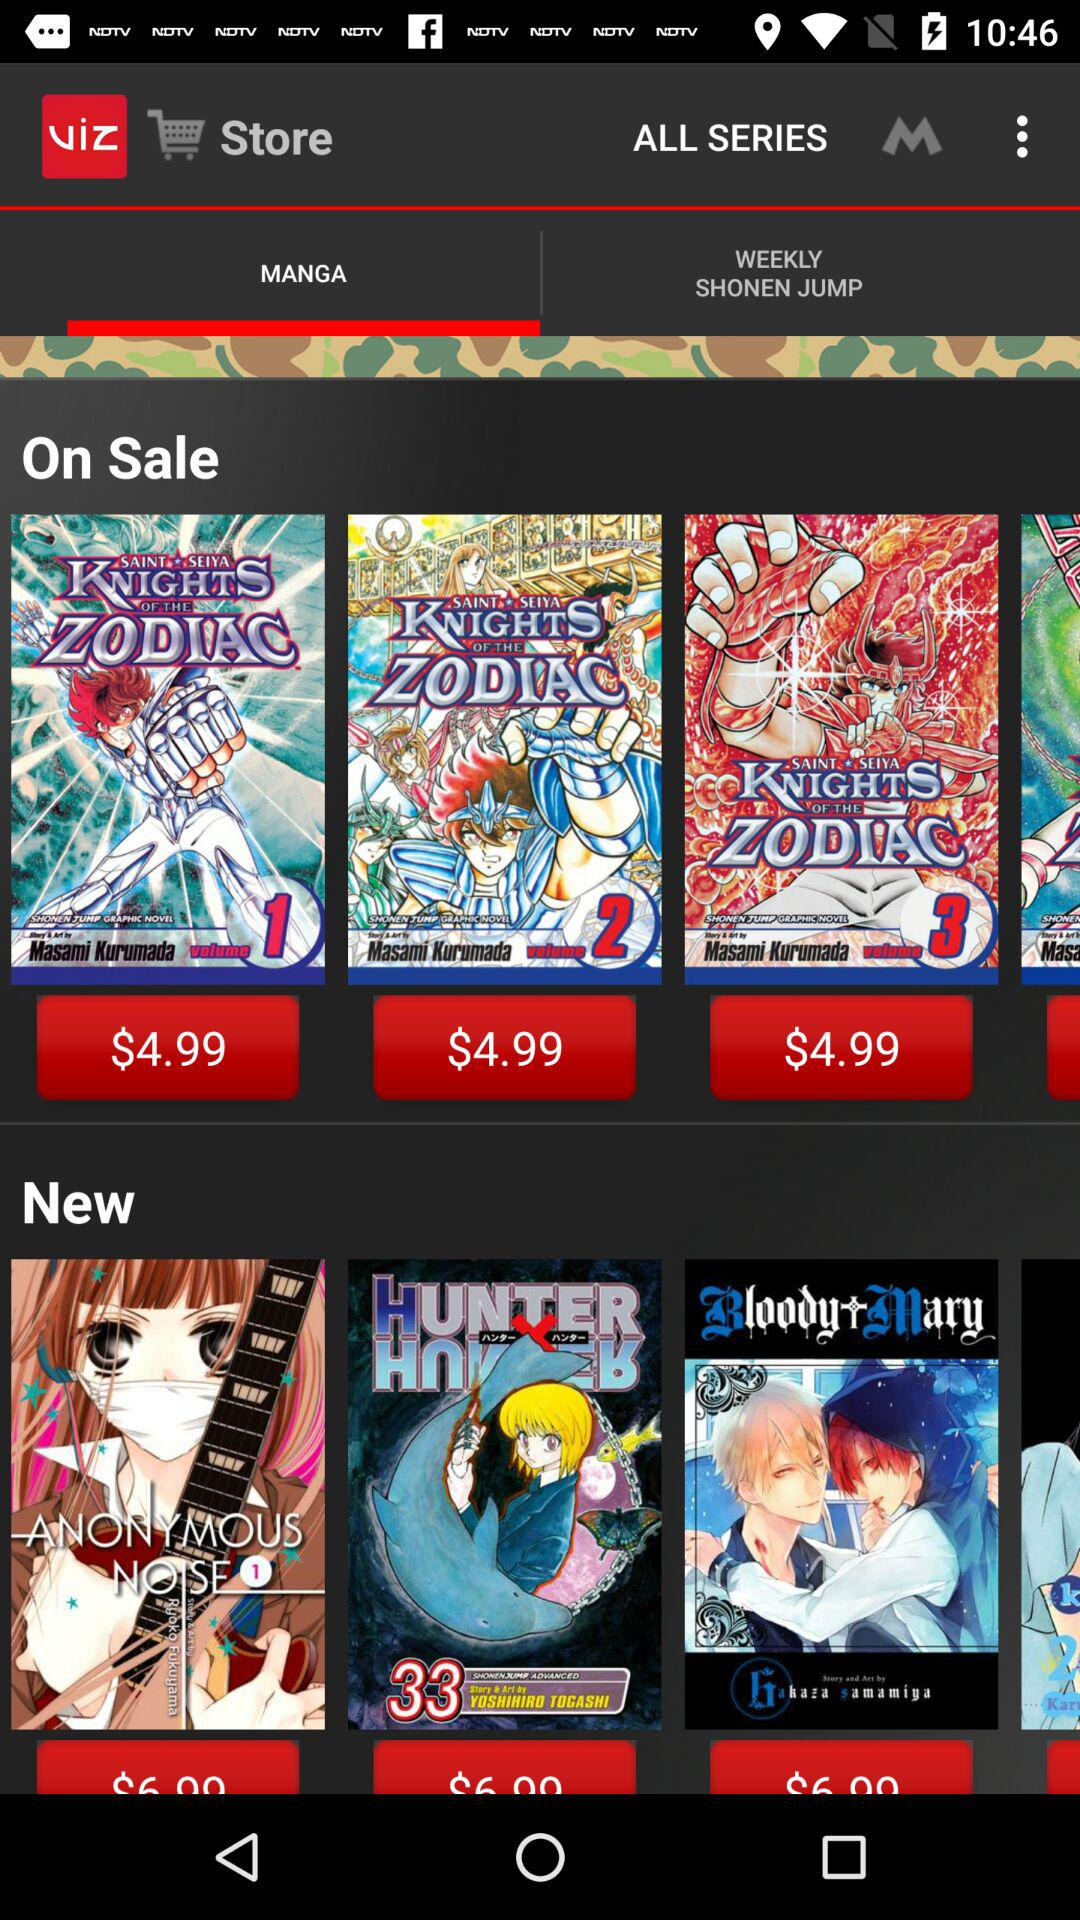What is the price of the books in the "On Sale" category? The price of the books in the "On Sale" category is 4.99 dollars. 